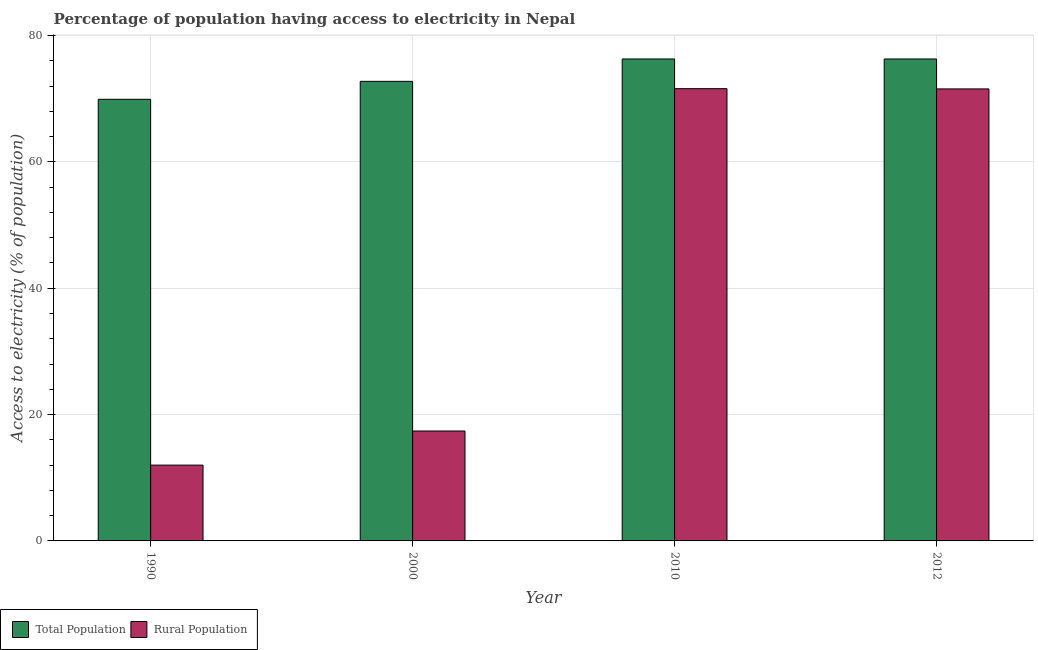How many different coloured bars are there?
Keep it short and to the point. 2. Are the number of bars per tick equal to the number of legend labels?
Give a very brief answer. Yes. Are the number of bars on each tick of the X-axis equal?
Offer a terse response. Yes. How many bars are there on the 3rd tick from the right?
Your answer should be compact. 2. In how many cases, is the number of bars for a given year not equal to the number of legend labels?
Ensure brevity in your answer.  0. What is the percentage of population having access to electricity in 2000?
Provide a short and direct response. 72.76. Across all years, what is the maximum percentage of population having access to electricity?
Your answer should be very brief. 76.3. What is the total percentage of rural population having access to electricity in the graph?
Provide a succinct answer. 172.56. What is the difference between the percentage of population having access to electricity in 1990 and that in 2000?
Keep it short and to the point. -2.84. What is the difference between the percentage of population having access to electricity in 1990 and the percentage of rural population having access to electricity in 2000?
Your response must be concise. -2.84. What is the average percentage of rural population having access to electricity per year?
Provide a short and direct response. 43.14. What is the ratio of the percentage of rural population having access to electricity in 1990 to that in 2010?
Keep it short and to the point. 0.17. What is the difference between the highest and the second highest percentage of rural population having access to electricity?
Your answer should be compact. 0.04. What is the difference between the highest and the lowest percentage of population having access to electricity?
Provide a succinct answer. 6.38. What does the 1st bar from the left in 2012 represents?
Offer a terse response. Total Population. What does the 2nd bar from the right in 2000 represents?
Keep it short and to the point. Total Population. How many years are there in the graph?
Keep it short and to the point. 4. What is the difference between two consecutive major ticks on the Y-axis?
Ensure brevity in your answer.  20. Does the graph contain grids?
Your answer should be compact. Yes. Where does the legend appear in the graph?
Give a very brief answer. Bottom left. How many legend labels are there?
Your answer should be very brief. 2. What is the title of the graph?
Provide a short and direct response. Percentage of population having access to electricity in Nepal. Does "Not attending school" appear as one of the legend labels in the graph?
Provide a short and direct response. No. What is the label or title of the X-axis?
Provide a succinct answer. Year. What is the label or title of the Y-axis?
Provide a succinct answer. Access to electricity (% of population). What is the Access to electricity (% of population) of Total Population in 1990?
Ensure brevity in your answer.  69.92. What is the Access to electricity (% of population) in Rural Population in 1990?
Provide a short and direct response. 12. What is the Access to electricity (% of population) of Total Population in 2000?
Offer a terse response. 72.76. What is the Access to electricity (% of population) of Total Population in 2010?
Offer a terse response. 76.3. What is the Access to electricity (% of population) of Rural Population in 2010?
Make the answer very short. 71.6. What is the Access to electricity (% of population) in Total Population in 2012?
Make the answer very short. 76.3. What is the Access to electricity (% of population) in Rural Population in 2012?
Make the answer very short. 71.56. Across all years, what is the maximum Access to electricity (% of population) of Total Population?
Your response must be concise. 76.3. Across all years, what is the maximum Access to electricity (% of population) in Rural Population?
Your answer should be very brief. 71.6. Across all years, what is the minimum Access to electricity (% of population) in Total Population?
Ensure brevity in your answer.  69.92. Across all years, what is the minimum Access to electricity (% of population) in Rural Population?
Offer a terse response. 12. What is the total Access to electricity (% of population) of Total Population in the graph?
Keep it short and to the point. 295.27. What is the total Access to electricity (% of population) in Rural Population in the graph?
Make the answer very short. 172.56. What is the difference between the Access to electricity (% of population) in Total Population in 1990 and that in 2000?
Keep it short and to the point. -2.84. What is the difference between the Access to electricity (% of population) of Rural Population in 1990 and that in 2000?
Make the answer very short. -5.4. What is the difference between the Access to electricity (% of population) of Total Population in 1990 and that in 2010?
Offer a very short reply. -6.38. What is the difference between the Access to electricity (% of population) in Rural Population in 1990 and that in 2010?
Offer a terse response. -59.6. What is the difference between the Access to electricity (% of population) of Total Population in 1990 and that in 2012?
Offer a very short reply. -6.38. What is the difference between the Access to electricity (% of population) in Rural Population in 1990 and that in 2012?
Your answer should be compact. -59.56. What is the difference between the Access to electricity (% of population) in Total Population in 2000 and that in 2010?
Offer a terse response. -3.54. What is the difference between the Access to electricity (% of population) of Rural Population in 2000 and that in 2010?
Give a very brief answer. -54.2. What is the difference between the Access to electricity (% of population) in Total Population in 2000 and that in 2012?
Keep it short and to the point. -3.54. What is the difference between the Access to electricity (% of population) of Rural Population in 2000 and that in 2012?
Your response must be concise. -54.16. What is the difference between the Access to electricity (% of population) in Total Population in 1990 and the Access to electricity (% of population) in Rural Population in 2000?
Your response must be concise. 52.52. What is the difference between the Access to electricity (% of population) of Total Population in 1990 and the Access to electricity (% of population) of Rural Population in 2010?
Provide a succinct answer. -1.68. What is the difference between the Access to electricity (% of population) in Total Population in 1990 and the Access to electricity (% of population) in Rural Population in 2012?
Provide a short and direct response. -1.64. What is the difference between the Access to electricity (% of population) in Total Population in 2000 and the Access to electricity (% of population) in Rural Population in 2010?
Give a very brief answer. 1.16. What is the difference between the Access to electricity (% of population) of Total Population in 2000 and the Access to electricity (% of population) of Rural Population in 2012?
Provide a succinct answer. 1.2. What is the difference between the Access to electricity (% of population) in Total Population in 2010 and the Access to electricity (% of population) in Rural Population in 2012?
Offer a very short reply. 4.74. What is the average Access to electricity (% of population) of Total Population per year?
Make the answer very short. 73.82. What is the average Access to electricity (% of population) in Rural Population per year?
Your answer should be compact. 43.14. In the year 1990, what is the difference between the Access to electricity (% of population) of Total Population and Access to electricity (% of population) of Rural Population?
Provide a succinct answer. 57.92. In the year 2000, what is the difference between the Access to electricity (% of population) in Total Population and Access to electricity (% of population) in Rural Population?
Provide a succinct answer. 55.36. In the year 2012, what is the difference between the Access to electricity (% of population) in Total Population and Access to electricity (% of population) in Rural Population?
Provide a succinct answer. 4.74. What is the ratio of the Access to electricity (% of population) in Total Population in 1990 to that in 2000?
Ensure brevity in your answer.  0.96. What is the ratio of the Access to electricity (% of population) in Rural Population in 1990 to that in 2000?
Give a very brief answer. 0.69. What is the ratio of the Access to electricity (% of population) of Total Population in 1990 to that in 2010?
Offer a terse response. 0.92. What is the ratio of the Access to electricity (% of population) in Rural Population in 1990 to that in 2010?
Provide a short and direct response. 0.17. What is the ratio of the Access to electricity (% of population) of Total Population in 1990 to that in 2012?
Your answer should be compact. 0.92. What is the ratio of the Access to electricity (% of population) of Rural Population in 1990 to that in 2012?
Your answer should be compact. 0.17. What is the ratio of the Access to electricity (% of population) in Total Population in 2000 to that in 2010?
Make the answer very short. 0.95. What is the ratio of the Access to electricity (% of population) in Rural Population in 2000 to that in 2010?
Provide a short and direct response. 0.24. What is the ratio of the Access to electricity (% of population) of Total Population in 2000 to that in 2012?
Offer a very short reply. 0.95. What is the ratio of the Access to electricity (% of population) in Rural Population in 2000 to that in 2012?
Offer a terse response. 0.24. What is the ratio of the Access to electricity (% of population) of Total Population in 2010 to that in 2012?
Offer a terse response. 1. What is the difference between the highest and the lowest Access to electricity (% of population) in Total Population?
Offer a terse response. 6.38. What is the difference between the highest and the lowest Access to electricity (% of population) in Rural Population?
Offer a very short reply. 59.6. 